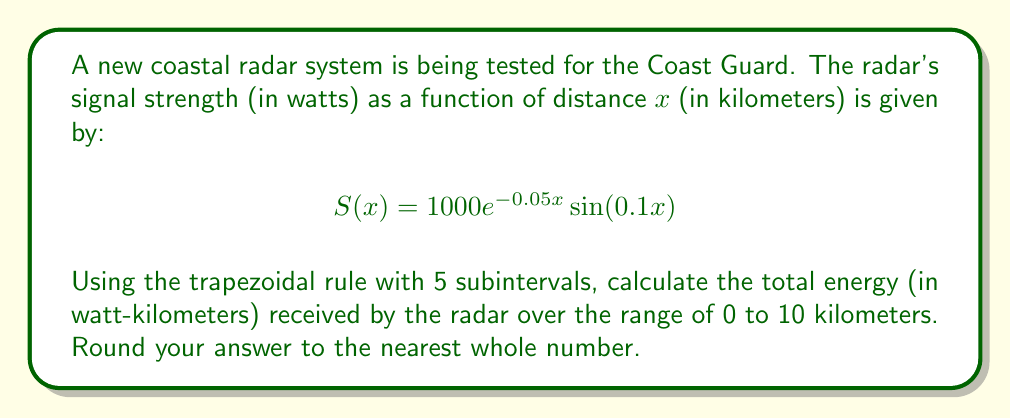Solve this math problem. To solve this problem, we'll use the trapezoidal rule for numerical integration:

1) The trapezoidal rule is given by:

   $$\int_{a}^{b} f(x)dx \approx \frac{h}{2}[f(x_0) + 2f(x_1) + 2f(x_2) + ... + 2f(x_{n-1}) + f(x_n)]$$

   where $h = \frac{b-a}{n}$, and $n$ is the number of subintervals.

2) In our case, $a=0$, $b=10$, and $n=5$. So, $h = \frac{10-0}{5} = 2$.

3) We need to calculate $S(x)$ at $x = 0, 2, 4, 6, 8,$ and $10$:

   $S(0) = 1000e^{-0.05(0)}\sin(0.1(0)) = 0$
   $S(2) = 1000e^{-0.05(2)}\sin(0.1(2)) \approx 190.03$
   $S(4) = 1000e^{-0.05(4)}\sin(0.1(4)) \approx 322.14$
   $S(6) = 1000e^{-0.05(6)}\sin(0.1(6)) \approx 367.90$
   $S(8) = 1000e^{-0.05(8)}\sin(0.1(8)) \approx 327.68$
   $S(10) = 1000e^{-0.05(10)}\sin(0.1(10)) \approx 227.47$

4) Applying the trapezoidal rule:

   $$\int_{0}^{10} S(x)dx \approx \frac{2}{2}[0 + 2(190.03) + 2(322.14) + 2(367.90) + 2(327.68) + 227.47]$$

5) Simplifying:

   $$\int_{0}^{10} S(x)dx \approx 1 \times [0 + 380.06 + 644.28 + 735.80 + 655.36 + 227.47] = 2642.97$$

6) Rounding to the nearest whole number: 2643 watt-kilometers.
Answer: 2643 watt-kilometers 